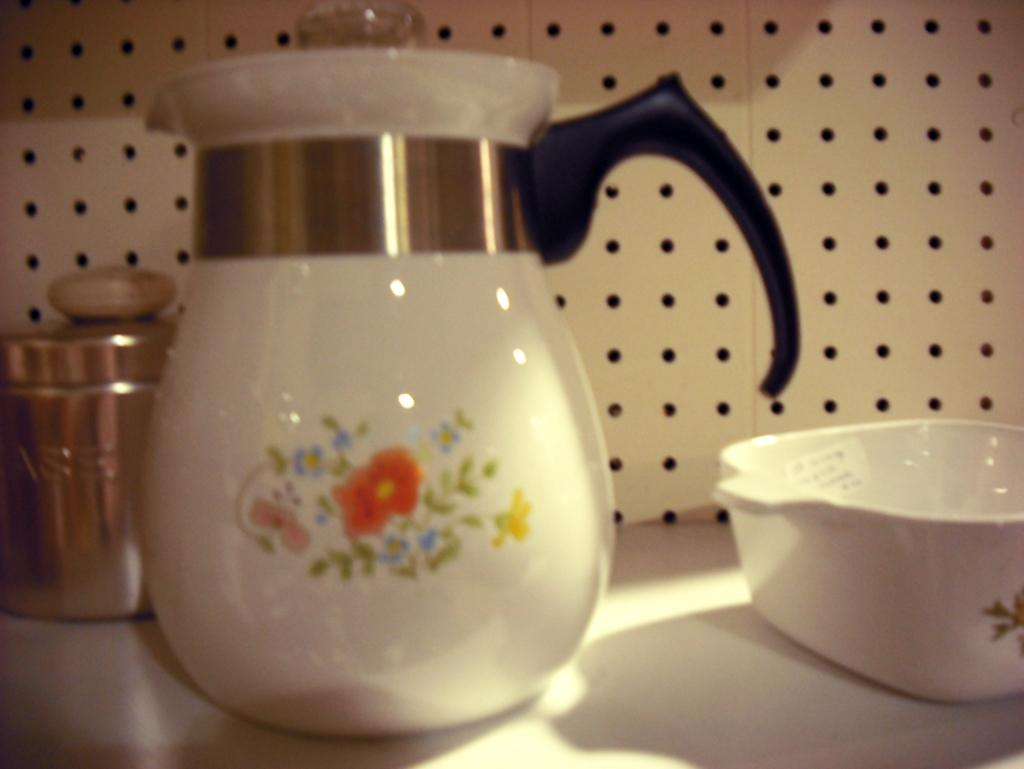What is the main object in the image? There is a jug in the image. What other object is near the jug? There is a ball beside the jug. What object is located behind the jug? There is a tin behind the jug. What type of music can be heard coming from the protest in the image? There is no protest or music present in the image; it only features a jug, a ball, and a tin. 